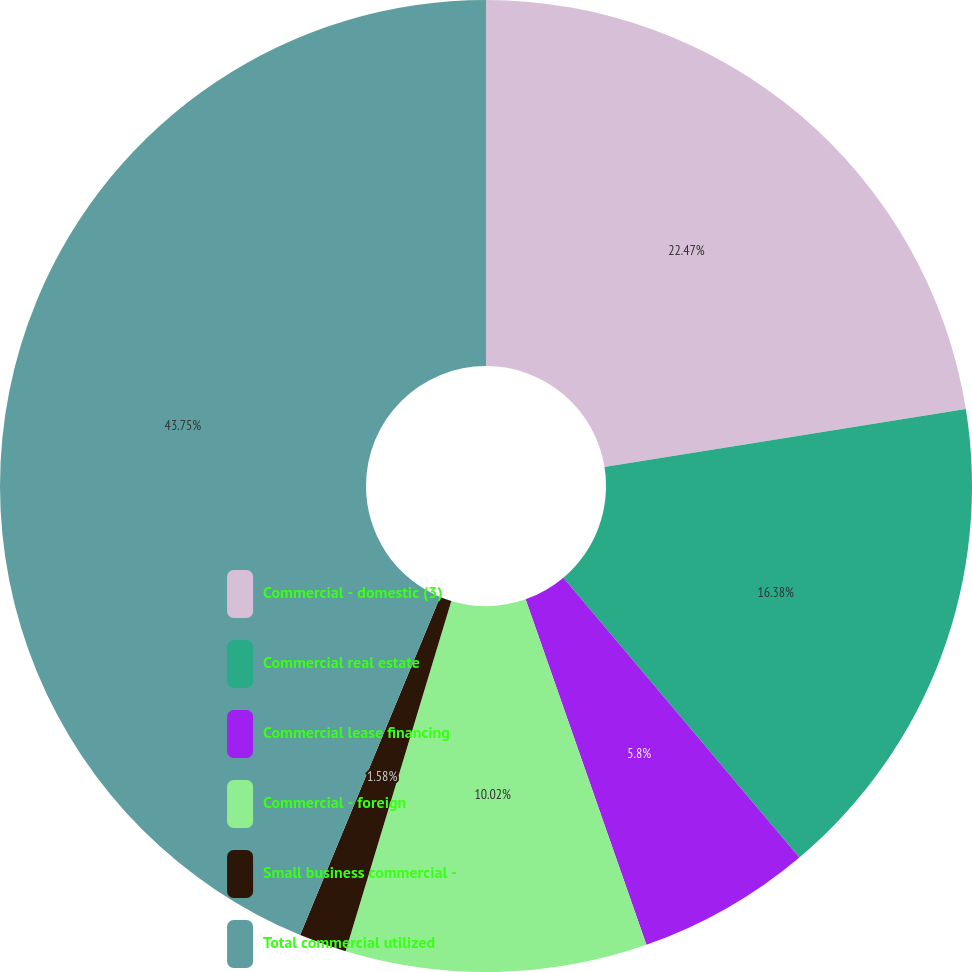Convert chart to OTSL. <chart><loc_0><loc_0><loc_500><loc_500><pie_chart><fcel>Commercial - domestic (3)<fcel>Commercial real estate<fcel>Commercial lease financing<fcel>Commercial - foreign<fcel>Small business commercial -<fcel>Total commercial utilized<nl><fcel>22.47%<fcel>16.38%<fcel>5.8%<fcel>10.02%<fcel>1.58%<fcel>43.76%<nl></chart> 